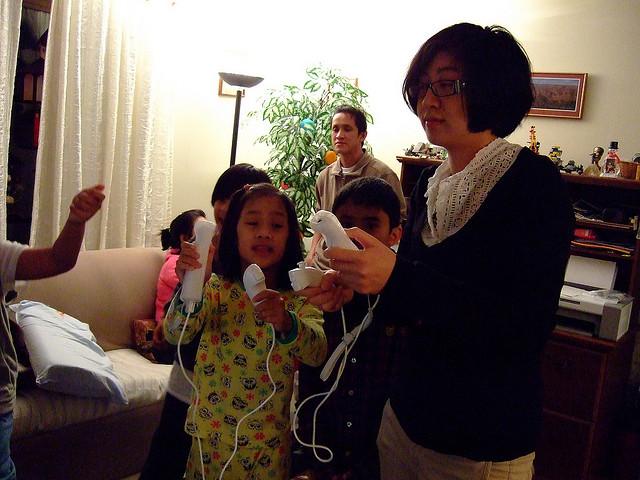What are they sitting on?
Short answer required. Couch. What race are the people?
Answer briefly. Asian. Are these people likely to be from the same country?
Write a very short answer. Yes. What are the people holding in their hands?
Answer briefly. Wii remotes. What part of the house is this scene?
Write a very short answer. Living room. What is the pattern of the older child's shirt?
Concise answer only. Floral. Is this a family?
Keep it brief. Yes. 